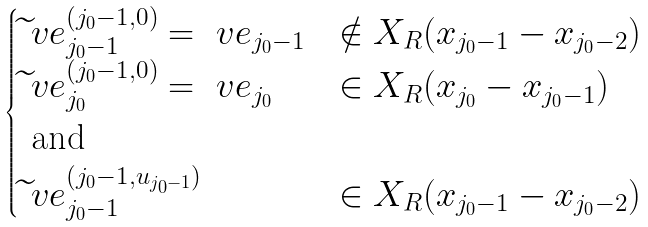<formula> <loc_0><loc_0><loc_500><loc_500>\begin{cases} \widetilde { \ } v e _ { j _ { 0 } - 1 } ^ { ( j _ { 0 } - 1 , 0 ) } = \ v e _ { j _ { 0 } - 1 } & \notin X _ { R } ( x _ { j _ { 0 } - 1 } - x _ { j _ { 0 } - 2 } ) \\ \widetilde { \ } v e _ { j _ { 0 } } ^ { ( j _ { 0 } - 1 , 0 ) } = \ v e _ { j _ { 0 } } & \in X _ { R } ( x _ { j _ { 0 } } - x _ { j _ { 0 } - 1 } ) \\ \text { and } \\ \widetilde { \ } v e _ { j _ { 0 } - 1 } ^ { ( j _ { 0 } - 1 , u _ { j _ { 0 } - 1 } ) } & \in X _ { R } ( x _ { j _ { 0 } - 1 } - x _ { j _ { 0 } - 2 } ) \\ \end{cases}</formula> 